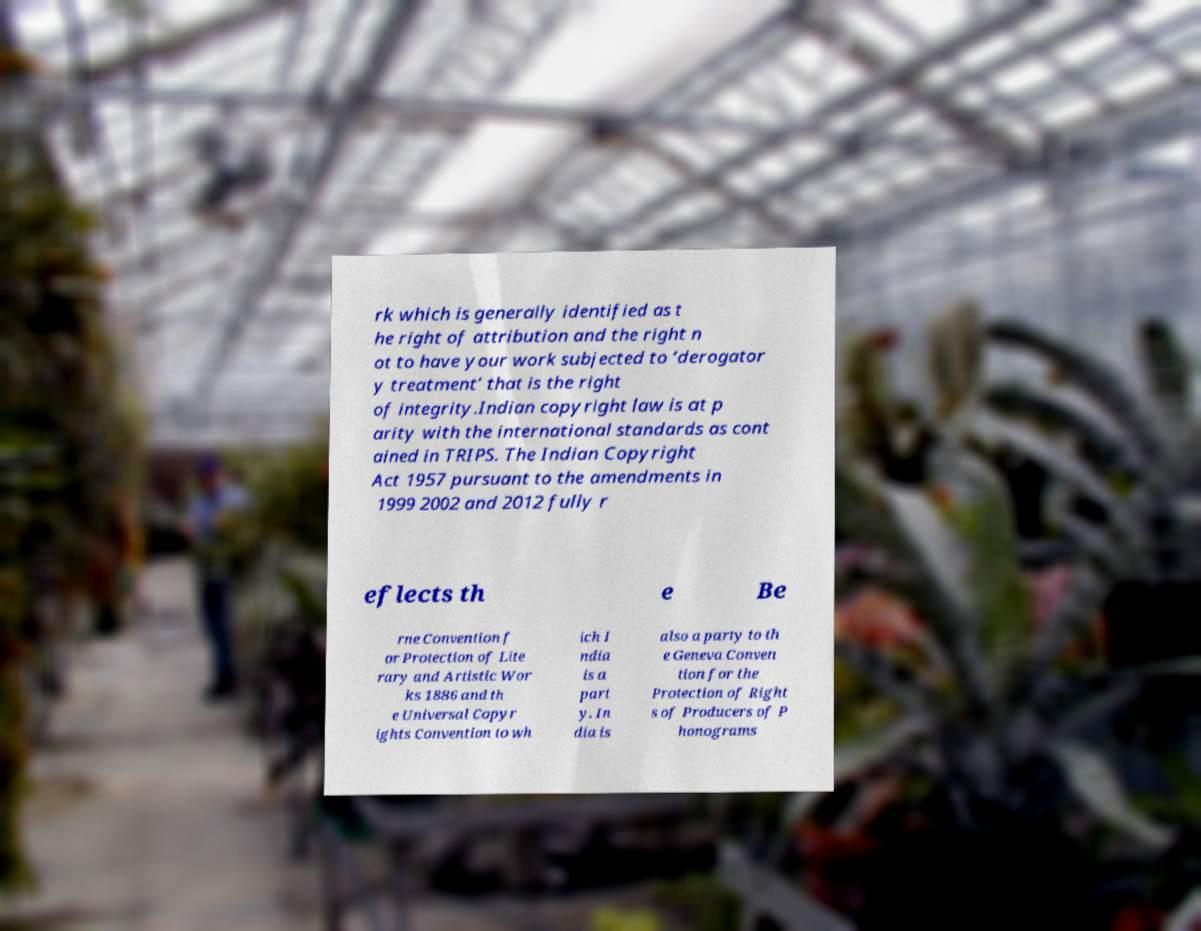For documentation purposes, I need the text within this image transcribed. Could you provide that? rk which is generally identified as t he right of attribution and the right n ot to have your work subjected to ‘derogator y treatment’ that is the right of integrity.Indian copyright law is at p arity with the international standards as cont ained in TRIPS. The Indian Copyright Act 1957 pursuant to the amendments in 1999 2002 and 2012 fully r eflects th e Be rne Convention f or Protection of Lite rary and Artistic Wor ks 1886 and th e Universal Copyr ights Convention to wh ich I ndia is a part y. In dia is also a party to th e Geneva Conven tion for the Protection of Right s of Producers of P honograms 